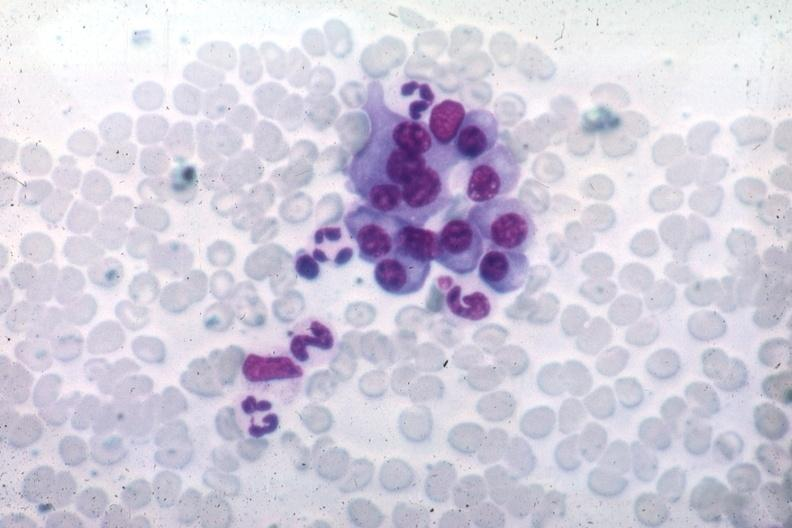what differentiated plasma cells source unknown?
Answer the question using a single word or phrase. Wrights typical well 